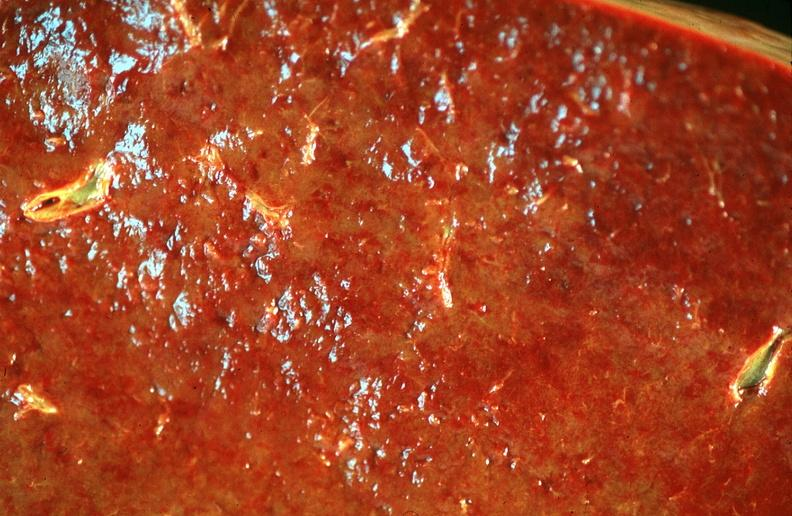where is this part in?
Answer the question using a single word or phrase. Spleen 